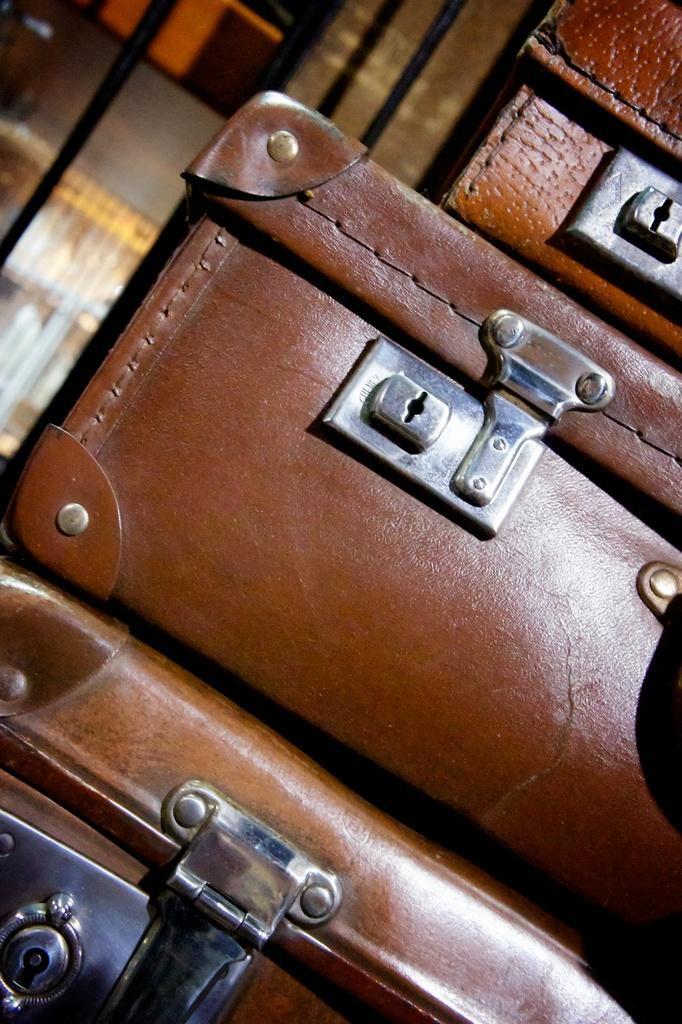In one or two sentences, can you explain what this image depicts? In this image i can see an object which is in brown color. 